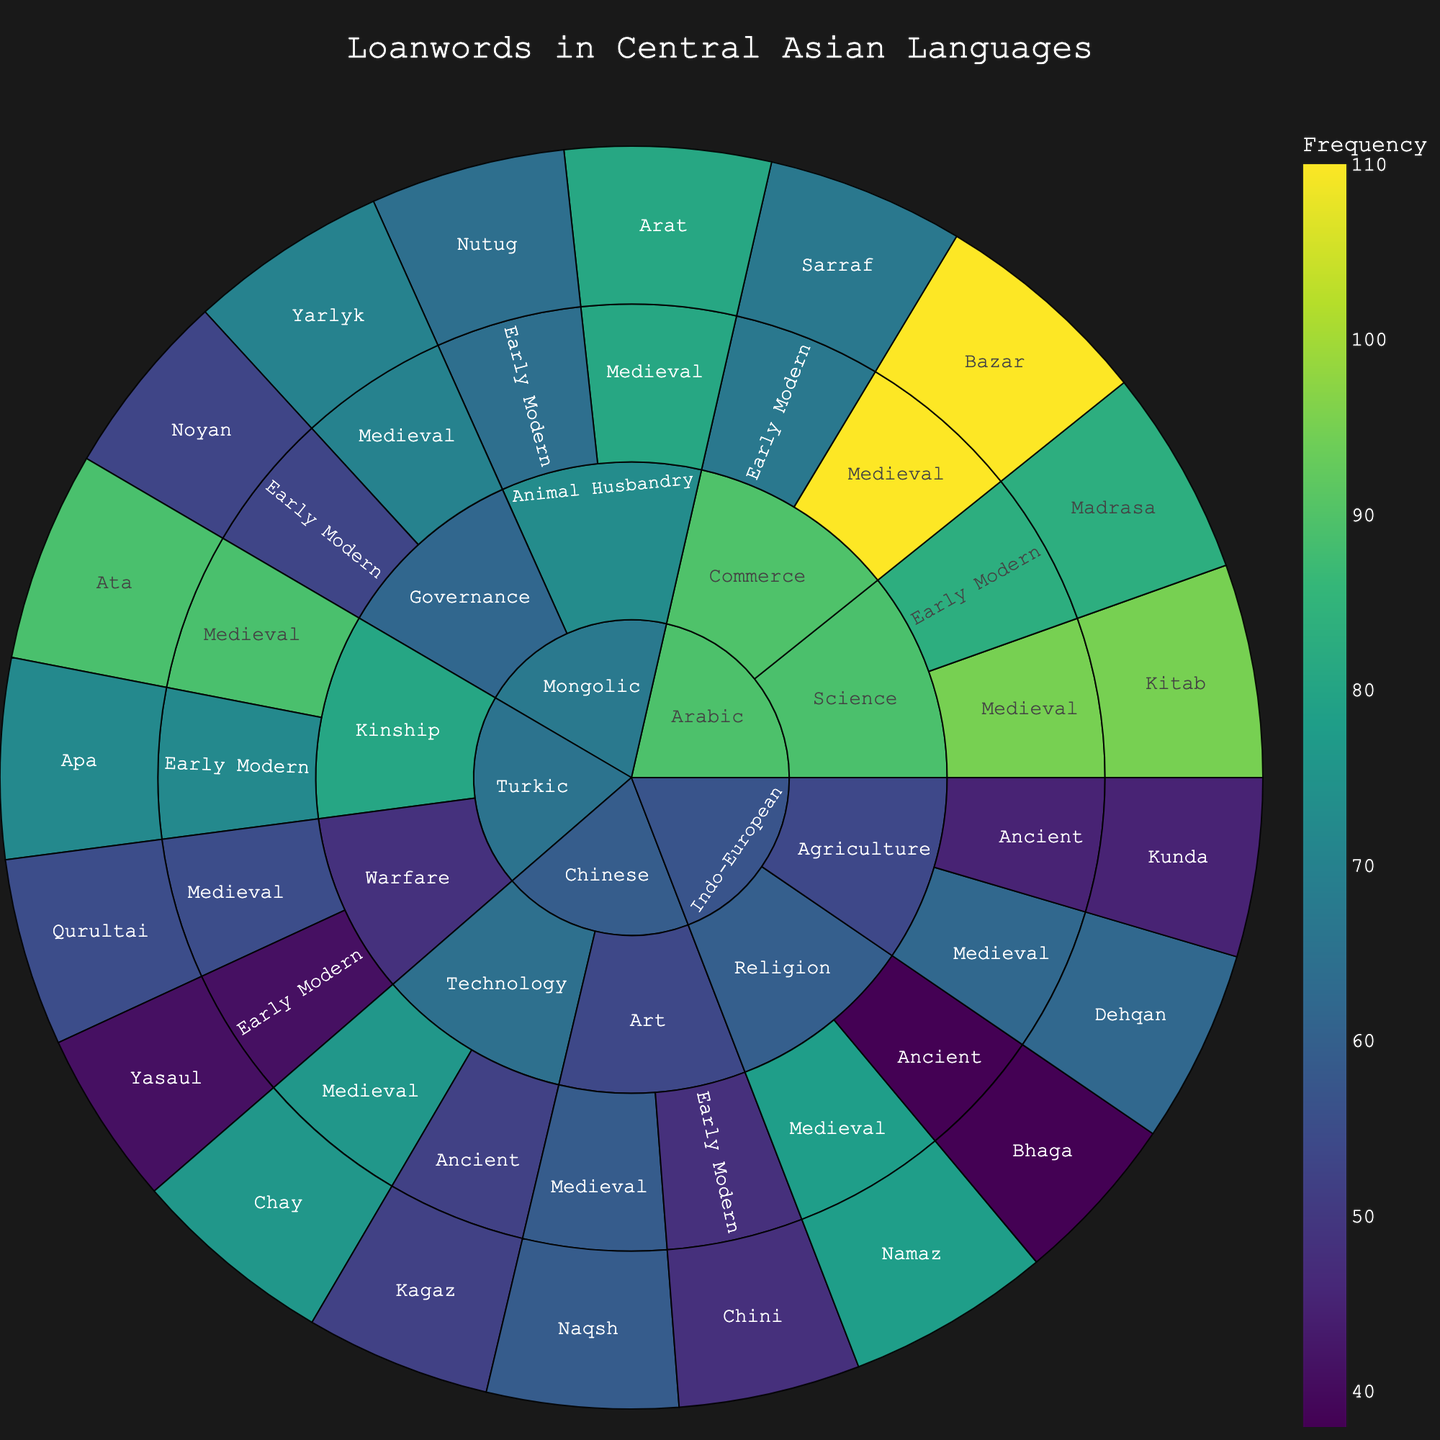What is the title of the sunburst plot? The title of the plot is usually displayed prominently at the top of the figure. The title consolidates what the visualization is about.
Answer: Loanwords in Central Asian Languages What origin has the most frequent loanword in the Medieval period? By looking at the Medieval period in each of the origins, compare the frequency values for each loanword. Arabic's "Bazar" has the highest frequency in the Medieval period.
Answer: Arabic Which semantic category in the Indo-European origin contains the word "Namaz"? First, locate the Indo-European segment. Within this, find the Religion category. The word "Namaz" is under this category.
Answer: Religion What is the total frequency of Turkic loanwords in the Early Modern period? Sum the frequencies of all Turkic loanwords in the Early Modern period: Yasaul (41) + Apa (72).
Answer: 113 Which word in the Arabic origin has the lowest frequency and in which time period and category is it found? Check all words under the Arabic origin and compare their frequencies. "Sarraf" with a frequency of 67 is the lowest, found in the Early Modern period under Commerce.
Answer: Sarraf, Early Modern, Commerce Which has more frequent loanwords in Agriculture: Indo-European or Turkic? Compare the frequencies of Indo-European's Agriculture words, Kunda (45) and Dehqan (62), to those of Turkic, which has no words in Agriculture.
Answer: Indo-European What is the difference in frequency of the words "Ata" and "Apa" in the Turkic origin? Note the frequencies of "Ata" (89) and "Apa" (72), then subtract the smaller from the larger: 89 - 72.
Answer: 17 Name two words associated with the Chinese origin in the Medieval time period. Locate the Chinese origin and then find the Medieval period within it. The words are "Chay" and "Naqsh".
Answer: Chay, Naqsh Which word in the Mongolic origin has the highest frequency and how does it compare to the lowest frequency word? Identify the frequencies of all Mongolic words and find the highest (Arat, 81) and the lowest (Noyan, 53). Compare the two values: 81 - 53.
Answer: Arat, difference of 28 